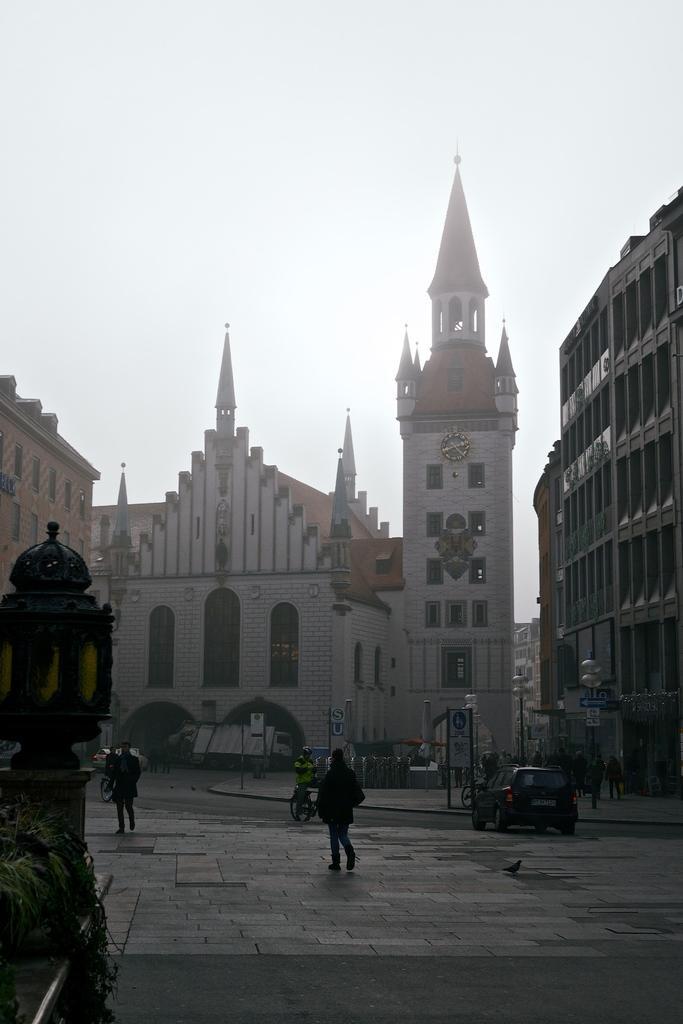Describe this image in one or two sentences. In this image I can see few persons walking on the road. I can also see few vehicles, light poles, trees. Background I can see a building in white color, I can also see sky in white color. 